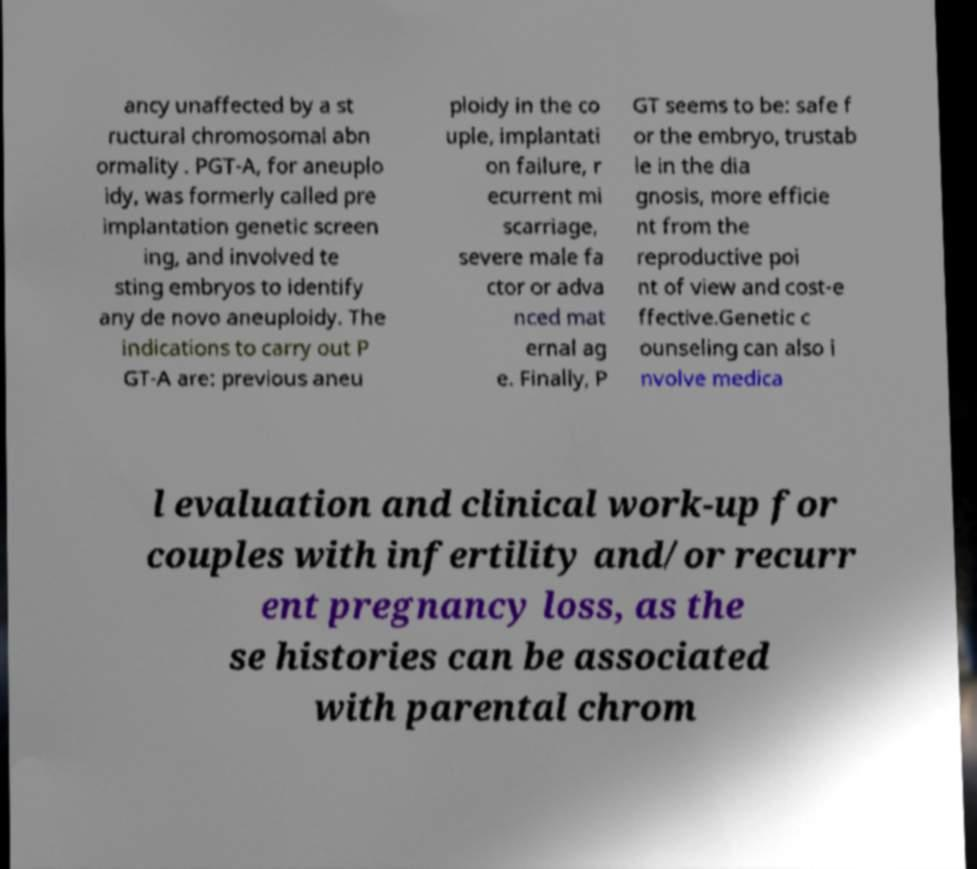Could you assist in decoding the text presented in this image and type it out clearly? ancy unaffected by a st ructural chromosomal abn ormality . PGT-A, for aneuplo idy, was formerly called pre implantation genetic screen ing, and involved te sting embryos to identify any de novo aneuploidy. The indications to carry out P GT-A are: previous aneu ploidy in the co uple, implantati on failure, r ecurrent mi scarriage, severe male fa ctor or adva nced mat ernal ag e. Finally, P GT seems to be: safe f or the embryo, trustab le in the dia gnosis, more efficie nt from the reproductive poi nt of view and cost-e ffective.Genetic c ounseling can also i nvolve medica l evaluation and clinical work-up for couples with infertility and/or recurr ent pregnancy loss, as the se histories can be associated with parental chrom 